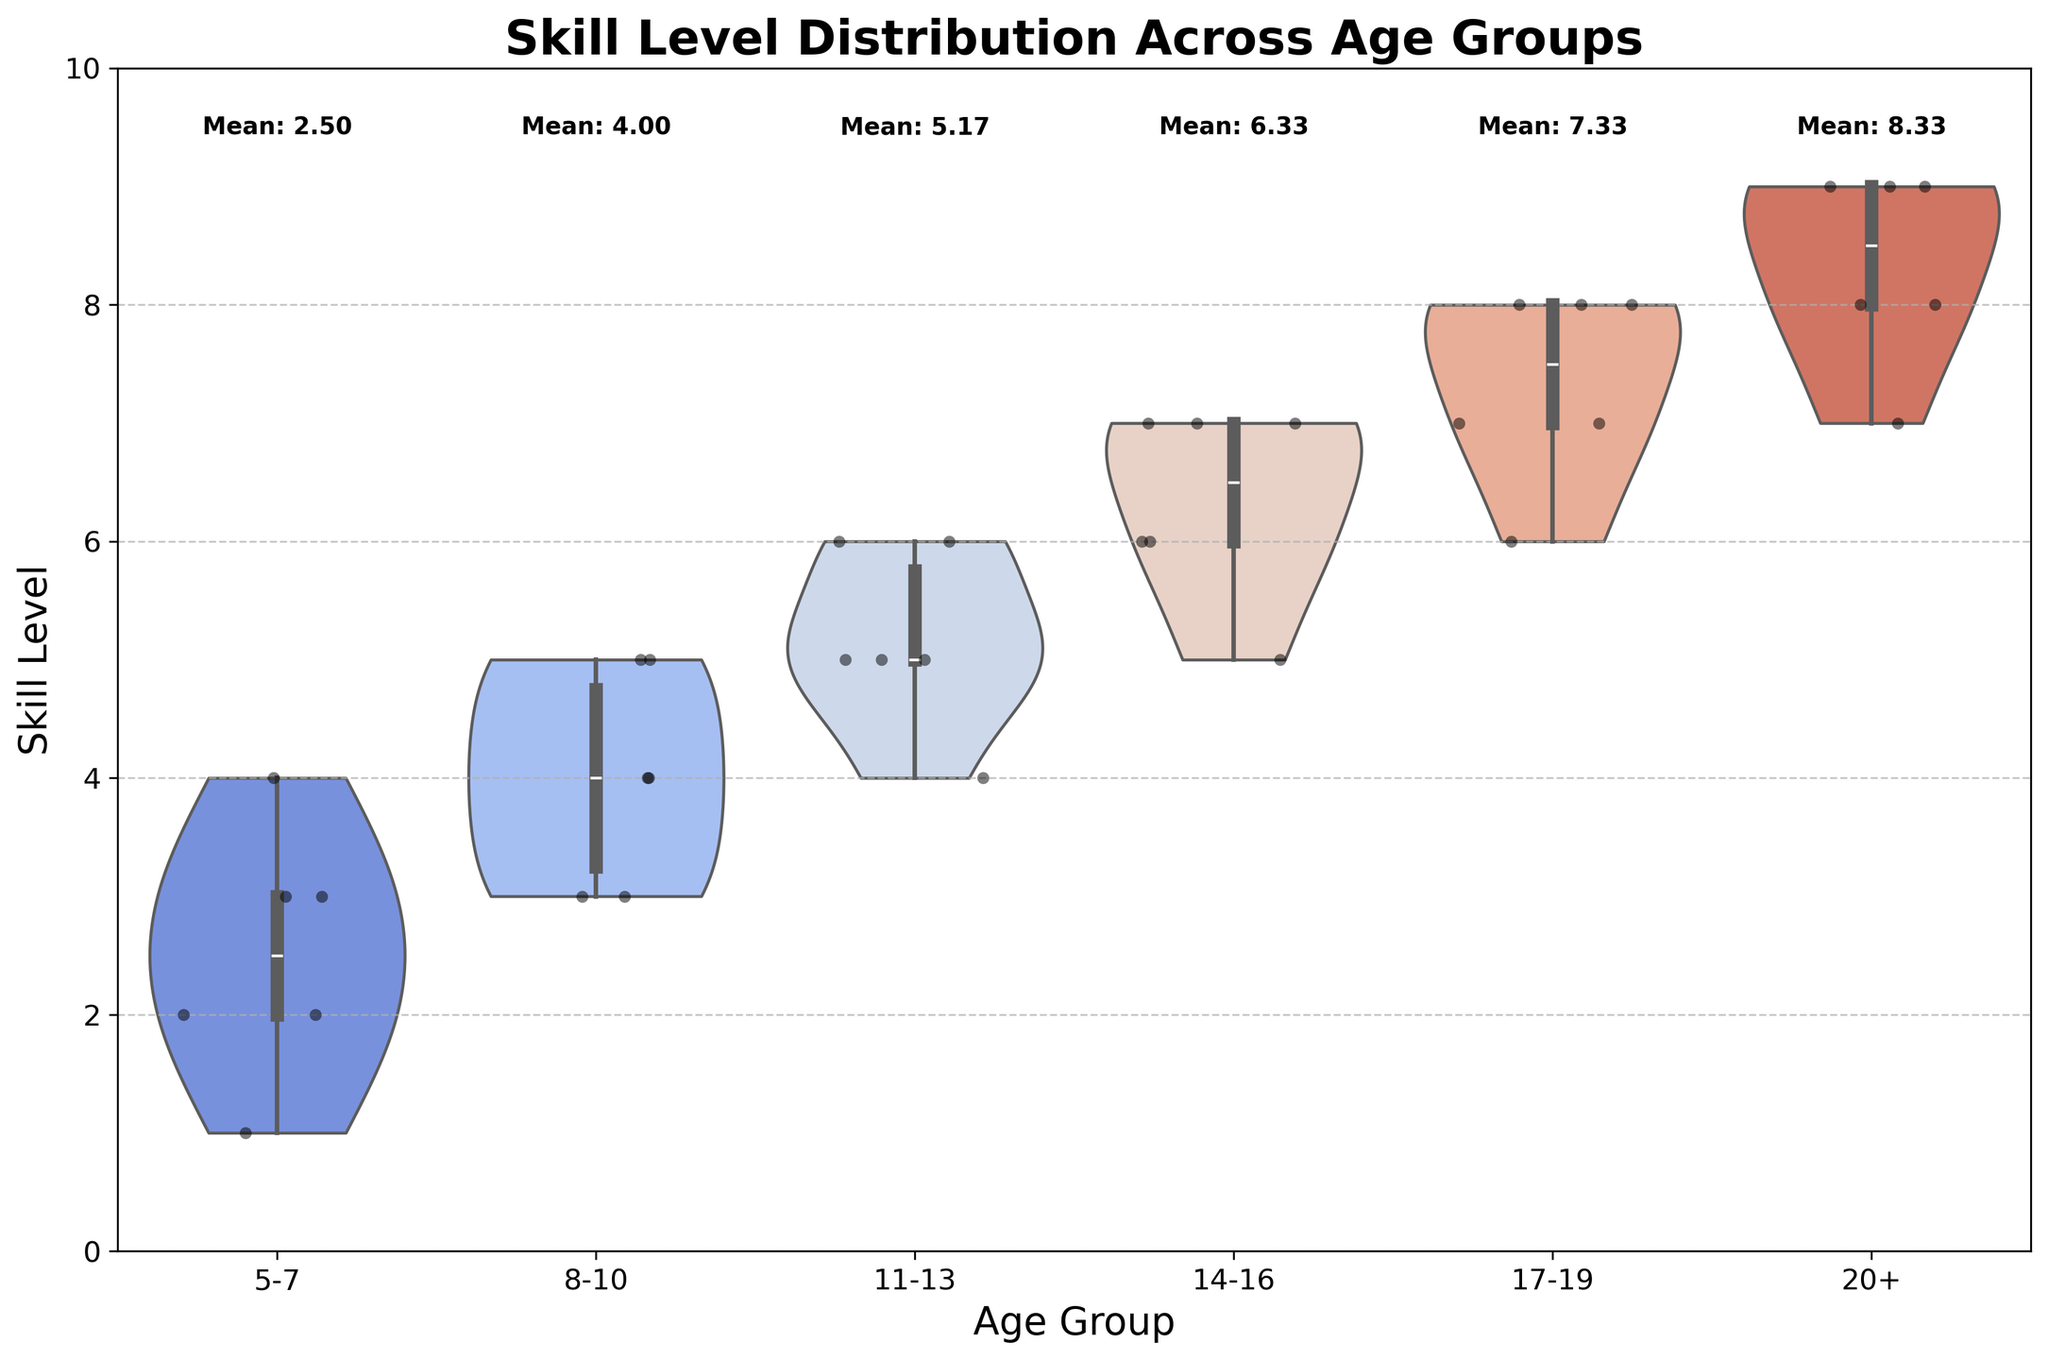What is the title of the chart? The title of the chart can directly be seen at the top of the chart. It is typically displayed in a larger and bold font compared to other text elements.
Answer: Skill Level Distribution Across Age Groups What age group has the highest mean skill level? By looking at the text annotations above each violin plot, the age group with the highest mean skill level can be identified. The annotation indicates the mean skill level for each age group.
Answer: 20+ Which age group has the widest distribution of skill levels? The width of the violin plot at different skill levels reflects the distribution density. The group with the most spread-out violin shape vertically has the widest distribution.
Answer: 17-19 Compare the median skill levels between the age groups 8-10 and 14-16. Which is higher? The inner box plots within each violin can be used to compare medians. The middle line of the box represents the median skill level. By comparing these lines between the age groups 8-10 and 14-16, we can determine which is higher.
Answer: 14-16 How many age groups have a mean skill level equal to or above 7? To answer this, look at the mean skill level annotations above each violin plot and count how many age groups have a mean value of 7 or above.
Answer: 3 What is the median skill level for the age group 5-7? The inner box plot within the violin for the age group 5-7 shows the median. The middle line of the box represents this value.
Answer: 3 What can you infer about the consistency of skill levels within the age group 20+ based on the violin plot? The narrow shape of the violin plot for the age group 20+ suggests a more consistent skill level among participants, as there is less variability in the distribution of data points.
Answer: High consistency How does the interquartile range (IQR) for the age group 11-13 compare to that of the age group 14-16? The IQR is represented by the height of the box in the box plot within each violin plot. By comparing the heights of the boxes for the age groups 11-13 and 14-16, we can infer which has a larger IQR.
Answer: Age group 11-13 has a slightly smaller IQR than 14-16 Which age group shows the most variability in skill levels? The group with the widest, bulkiest violin plot shape represents the most variability in skill levels across its distribution.
Answer: 17-19 What color palette is used in the violin plots? The overall gradient and hue of the violin plots indicate the color palette. In this case, the palette is specified as "coolwarm," which varies from cool to warm colors.
Answer: Coolwarm 